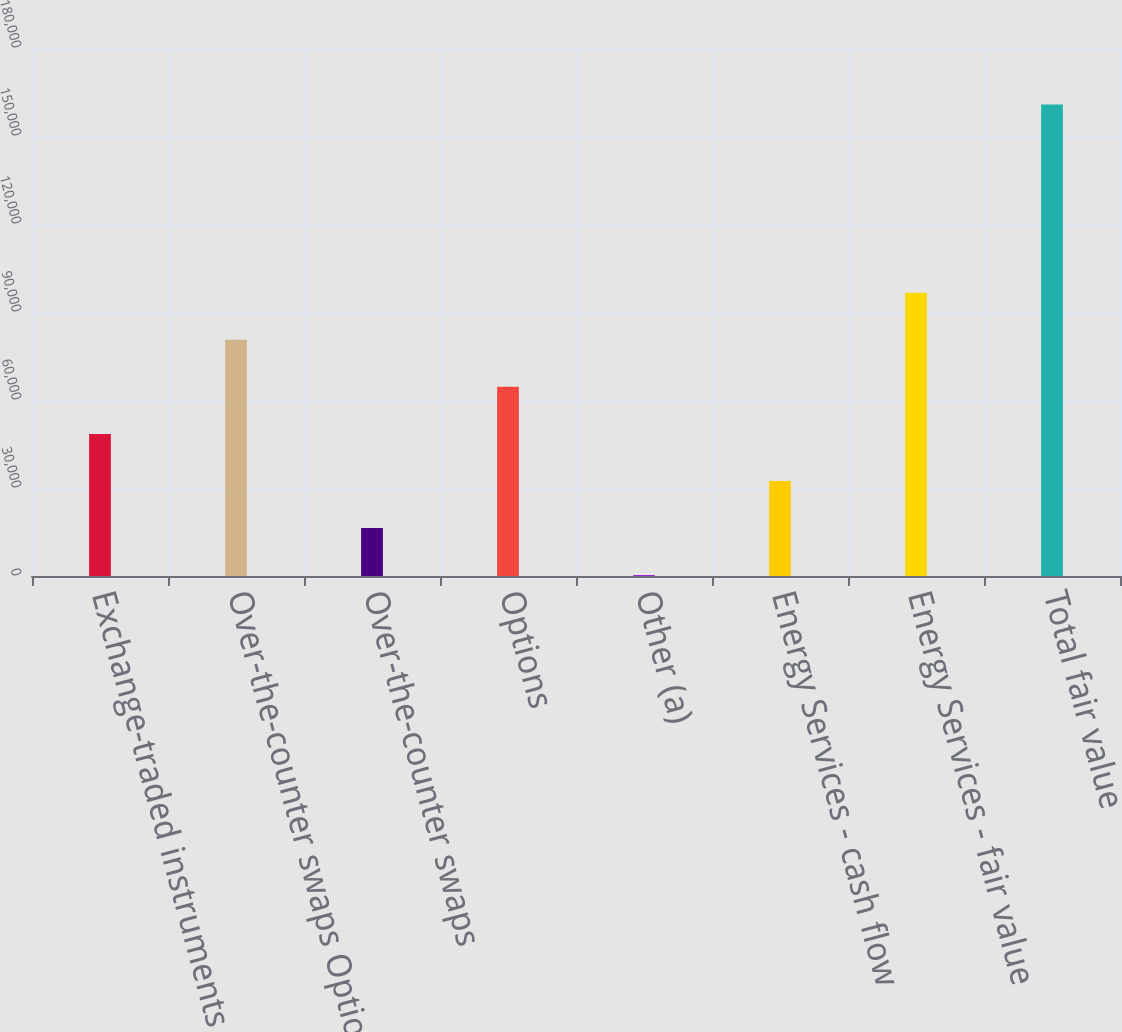Convert chart to OTSL. <chart><loc_0><loc_0><loc_500><loc_500><bar_chart><fcel>Exchange-traded instruments<fcel>Over-the-counter swaps Options<fcel>Over-the-counter swaps<fcel>Options<fcel>Other (a)<fcel>Energy Services - cash flow<fcel>Energy Services - fair value<fcel>Total fair value<nl><fcel>48430.1<fcel>80525.5<fcel>16334.7<fcel>64477.8<fcel>287<fcel>32382.4<fcel>96573.2<fcel>160764<nl></chart> 